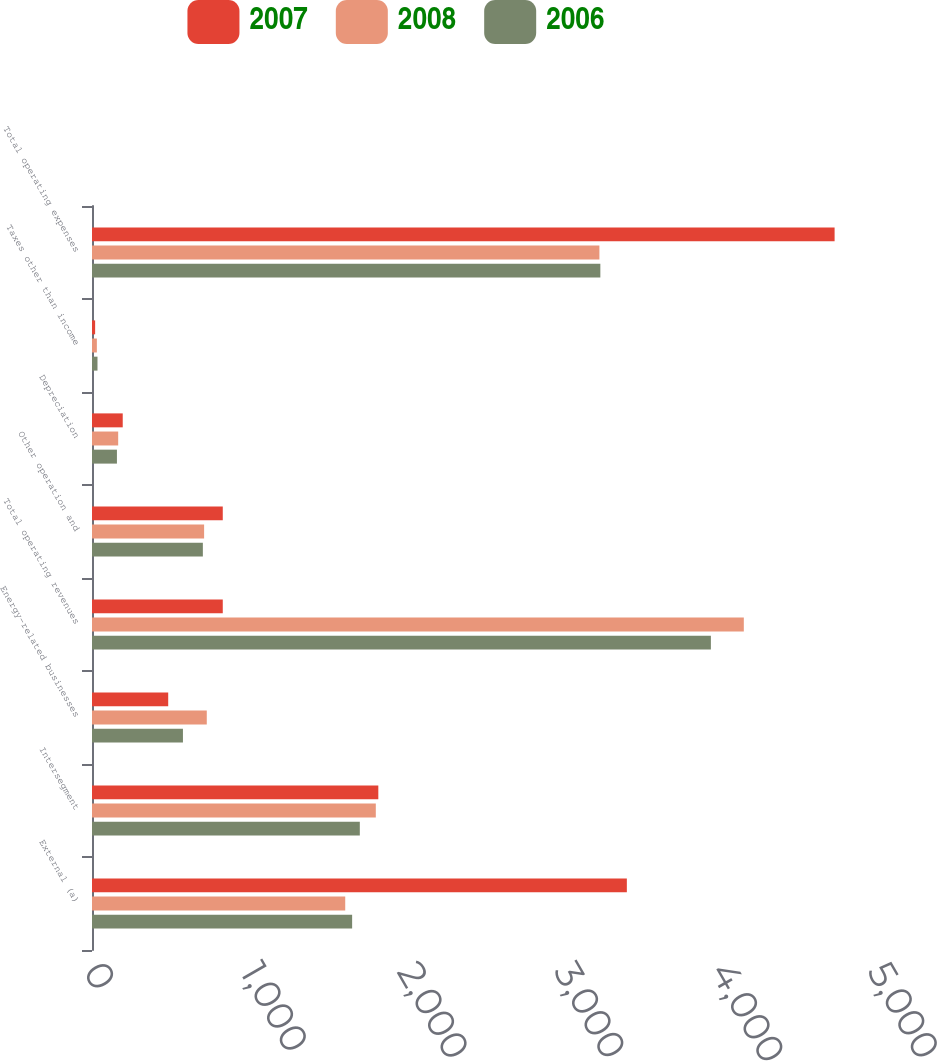Convert chart to OTSL. <chart><loc_0><loc_0><loc_500><loc_500><stacked_bar_chart><ecel><fcel>External (a)<fcel>Intersegment<fcel>Energy-related businesses<fcel>Total operating revenues<fcel>Other operation and<fcel>Depreciation<fcel>Taxes other than income<fcel>Total operating expenses<nl><fcel>2007<fcel>3411<fcel>1826<fcel>486<fcel>834<fcel>834<fcel>196<fcel>20<fcel>4736<nl><fcel>2008<fcel>1615<fcel>1810<fcel>732<fcel>4157<fcel>715<fcel>167<fcel>31<fcel>3236<nl><fcel>2006<fcel>1659<fcel>1708<fcel>580<fcel>3947<fcel>707<fcel>159<fcel>35<fcel>3242<nl></chart> 